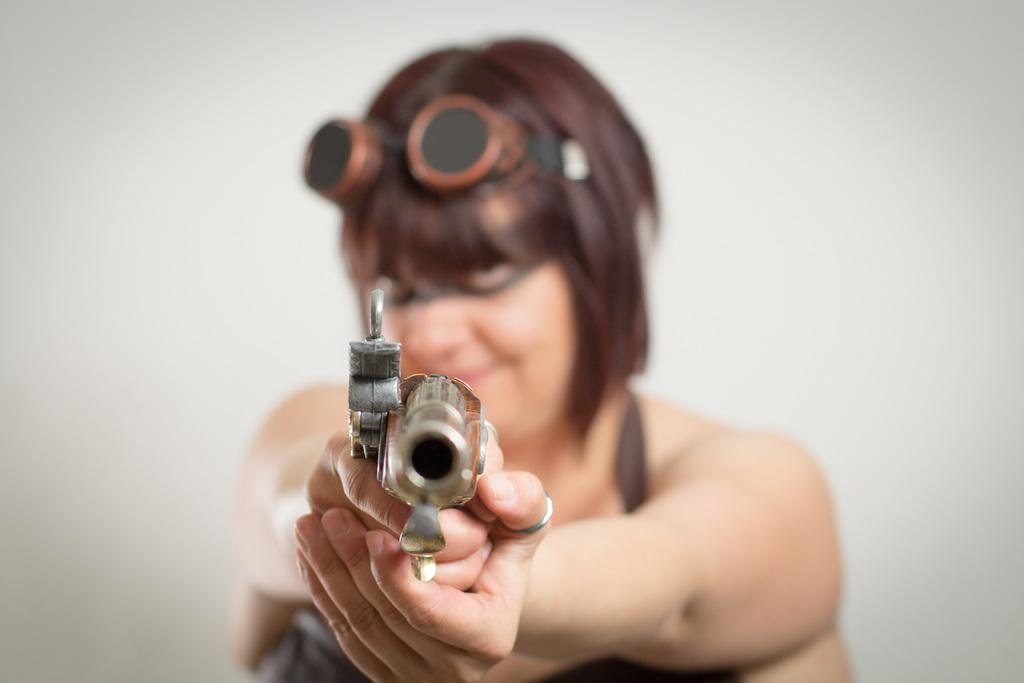What is present in the image? There is a person in the image. What is the person holding? The person is holding something. What can be seen in the background of the image? The background of the image is white. What type of slope can be seen in the image? There is no slope present in the image; the background is white. 